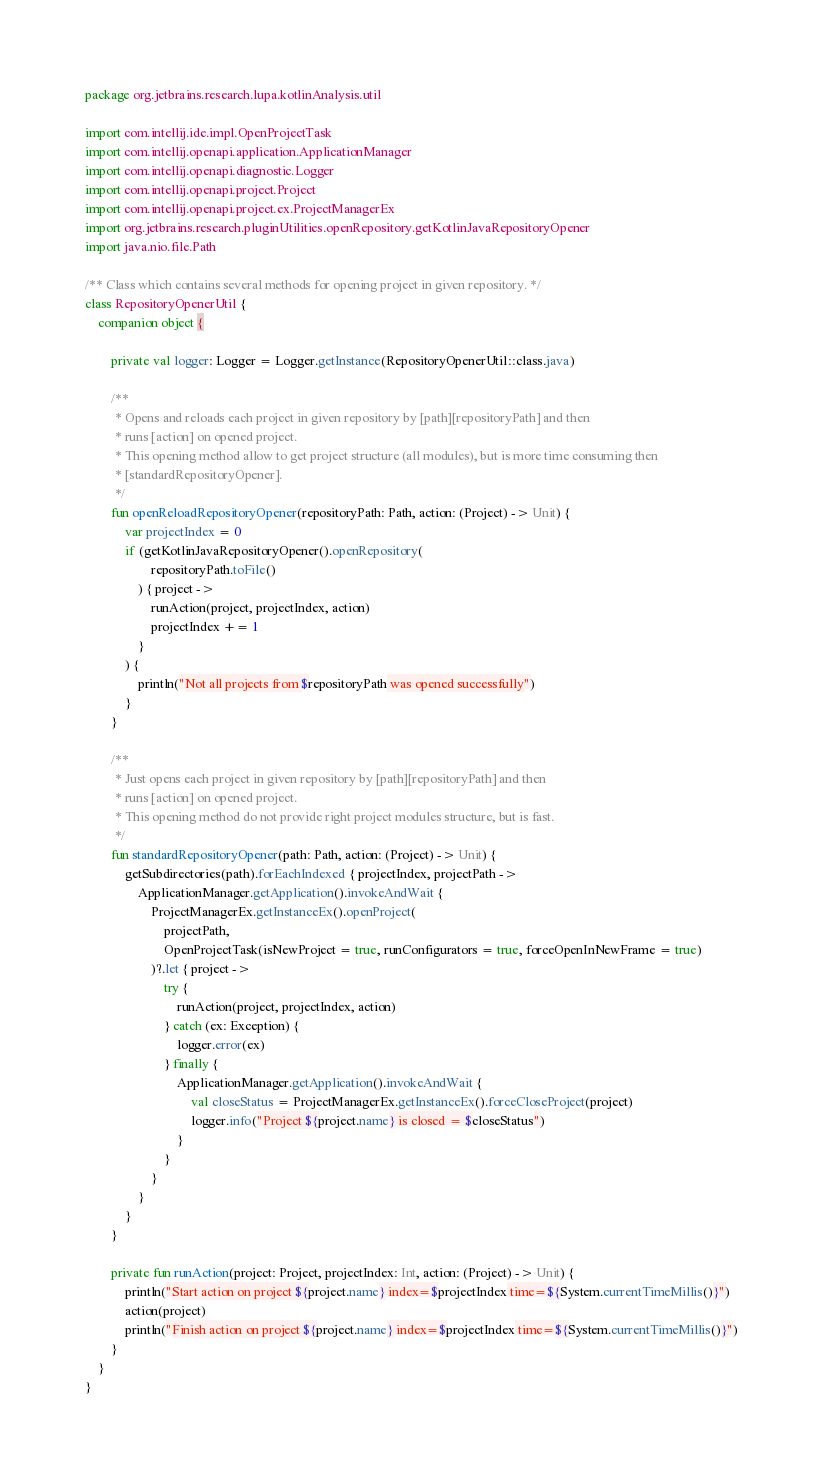Convert code to text. <code><loc_0><loc_0><loc_500><loc_500><_Kotlin_>package org.jetbrains.research.lupa.kotlinAnalysis.util

import com.intellij.ide.impl.OpenProjectTask
import com.intellij.openapi.application.ApplicationManager
import com.intellij.openapi.diagnostic.Logger
import com.intellij.openapi.project.Project
import com.intellij.openapi.project.ex.ProjectManagerEx
import org.jetbrains.research.pluginUtilities.openRepository.getKotlinJavaRepositoryOpener
import java.nio.file.Path

/** Class which contains several methods for opening project in given repository. */
class RepositoryOpenerUtil {
    companion object {

        private val logger: Logger = Logger.getInstance(RepositoryOpenerUtil::class.java)

        /**
         * Opens and reloads each project in given repository by [path][repositoryPath] and then
         * runs [action] on opened project.
         * This opening method allow to get project structure (all modules), but is more time consuming then
         * [standardRepositoryOpener].
         */
        fun openReloadRepositoryOpener(repositoryPath: Path, action: (Project) -> Unit) {
            var projectIndex = 0
            if (getKotlinJavaRepositoryOpener().openRepository(
                    repositoryPath.toFile()
                ) { project ->
                    runAction(project, projectIndex, action)
                    projectIndex += 1
                }
            ) {
                println("Not all projects from $repositoryPath was opened successfully")
            }
        }

        /**
         * Just opens each project in given repository by [path][repositoryPath] and then
         * runs [action] on opened project.
         * This opening method do not provide right project modules structure, but is fast.
         */
        fun standardRepositoryOpener(path: Path, action: (Project) -> Unit) {
            getSubdirectories(path).forEachIndexed { projectIndex, projectPath ->
                ApplicationManager.getApplication().invokeAndWait {
                    ProjectManagerEx.getInstanceEx().openProject(
                        projectPath,
                        OpenProjectTask(isNewProject = true, runConfigurators = true, forceOpenInNewFrame = true)
                    )?.let { project ->
                        try {
                            runAction(project, projectIndex, action)
                        } catch (ex: Exception) {
                            logger.error(ex)
                        } finally {
                            ApplicationManager.getApplication().invokeAndWait {
                                val closeStatus = ProjectManagerEx.getInstanceEx().forceCloseProject(project)
                                logger.info("Project ${project.name} is closed = $closeStatus")
                            }
                        }
                    }
                }
            }
        }

        private fun runAction(project: Project, projectIndex: Int, action: (Project) -> Unit) {
            println("Start action on project ${project.name} index=$projectIndex time=${System.currentTimeMillis()}")
            action(project)
            println("Finish action on project ${project.name} index=$projectIndex time=${System.currentTimeMillis()}")
        }
    }
}
</code> 